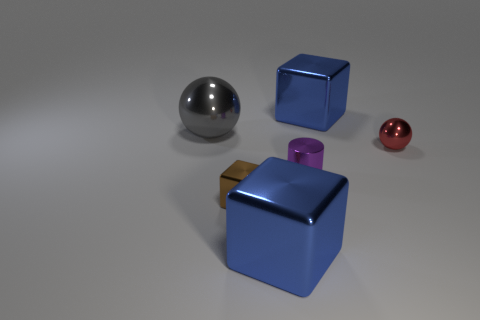Is there anything else that has the same material as the large gray sphere?
Your answer should be compact. Yes. How many things are either big blue blocks or big metallic objects that are behind the tiny red metallic thing?
Keep it short and to the point. 3. Is the size of the ball that is on the right side of the brown metallic object the same as the big gray shiny sphere?
Your answer should be compact. No. What number of other objects are the same shape as the red metallic thing?
Give a very brief answer. 1. What number of red things are tiny objects or large balls?
Provide a succinct answer. 1. There is a big metallic block behind the big shiny ball; is it the same color as the tiny shiny cylinder?
Ensure brevity in your answer.  No. There is a purple object that is made of the same material as the large ball; what shape is it?
Make the answer very short. Cylinder. What is the color of the metal thing that is both to the right of the cylinder and behind the small red metal thing?
Your answer should be very brief. Blue. What is the size of the blue block on the right side of the blue block that is in front of the tiny ball?
Offer a very short reply. Large. Are there any blocks of the same color as the big sphere?
Your answer should be very brief. No. 